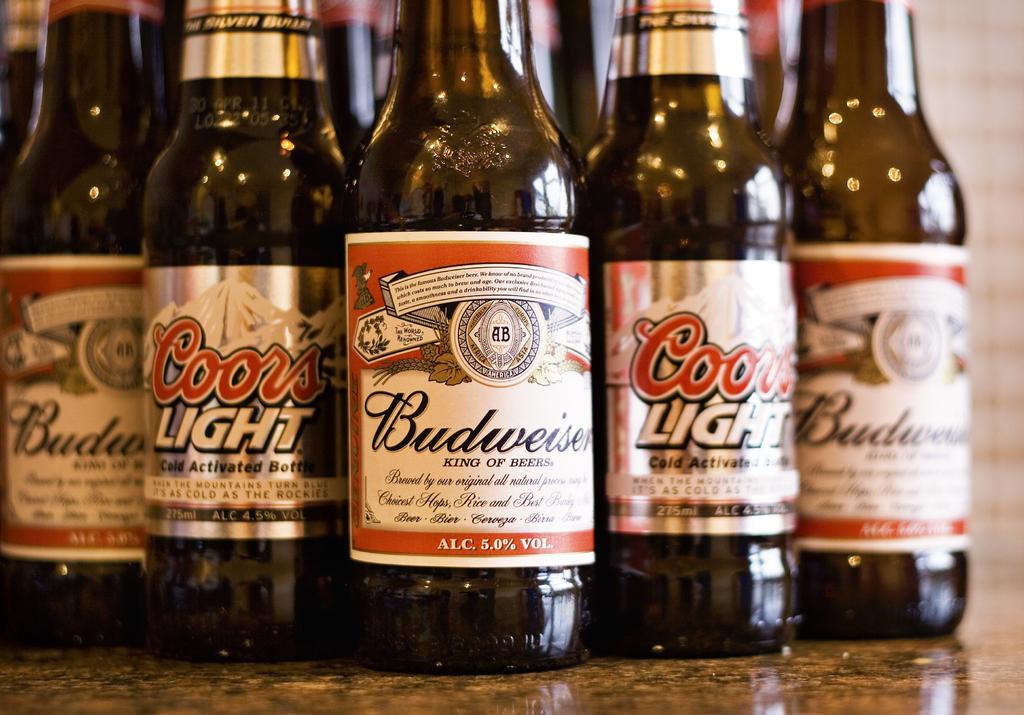What is the main object in the center of the image? There is a table in the center of the image. What is placed on the table? There are beer bottles on the table. What brand of beer is depicted on the bottles? The beer bottles have "Budweiser" written on them. Are there any labels or text on the beer bottles? Yes, there is text on the beer bottles. How does the wealth of the person in the image relate to the number of spoons they possess? There is no person or spoons present in the image, so it is not possible to determine any relationship between wealth and the number of spoons. 